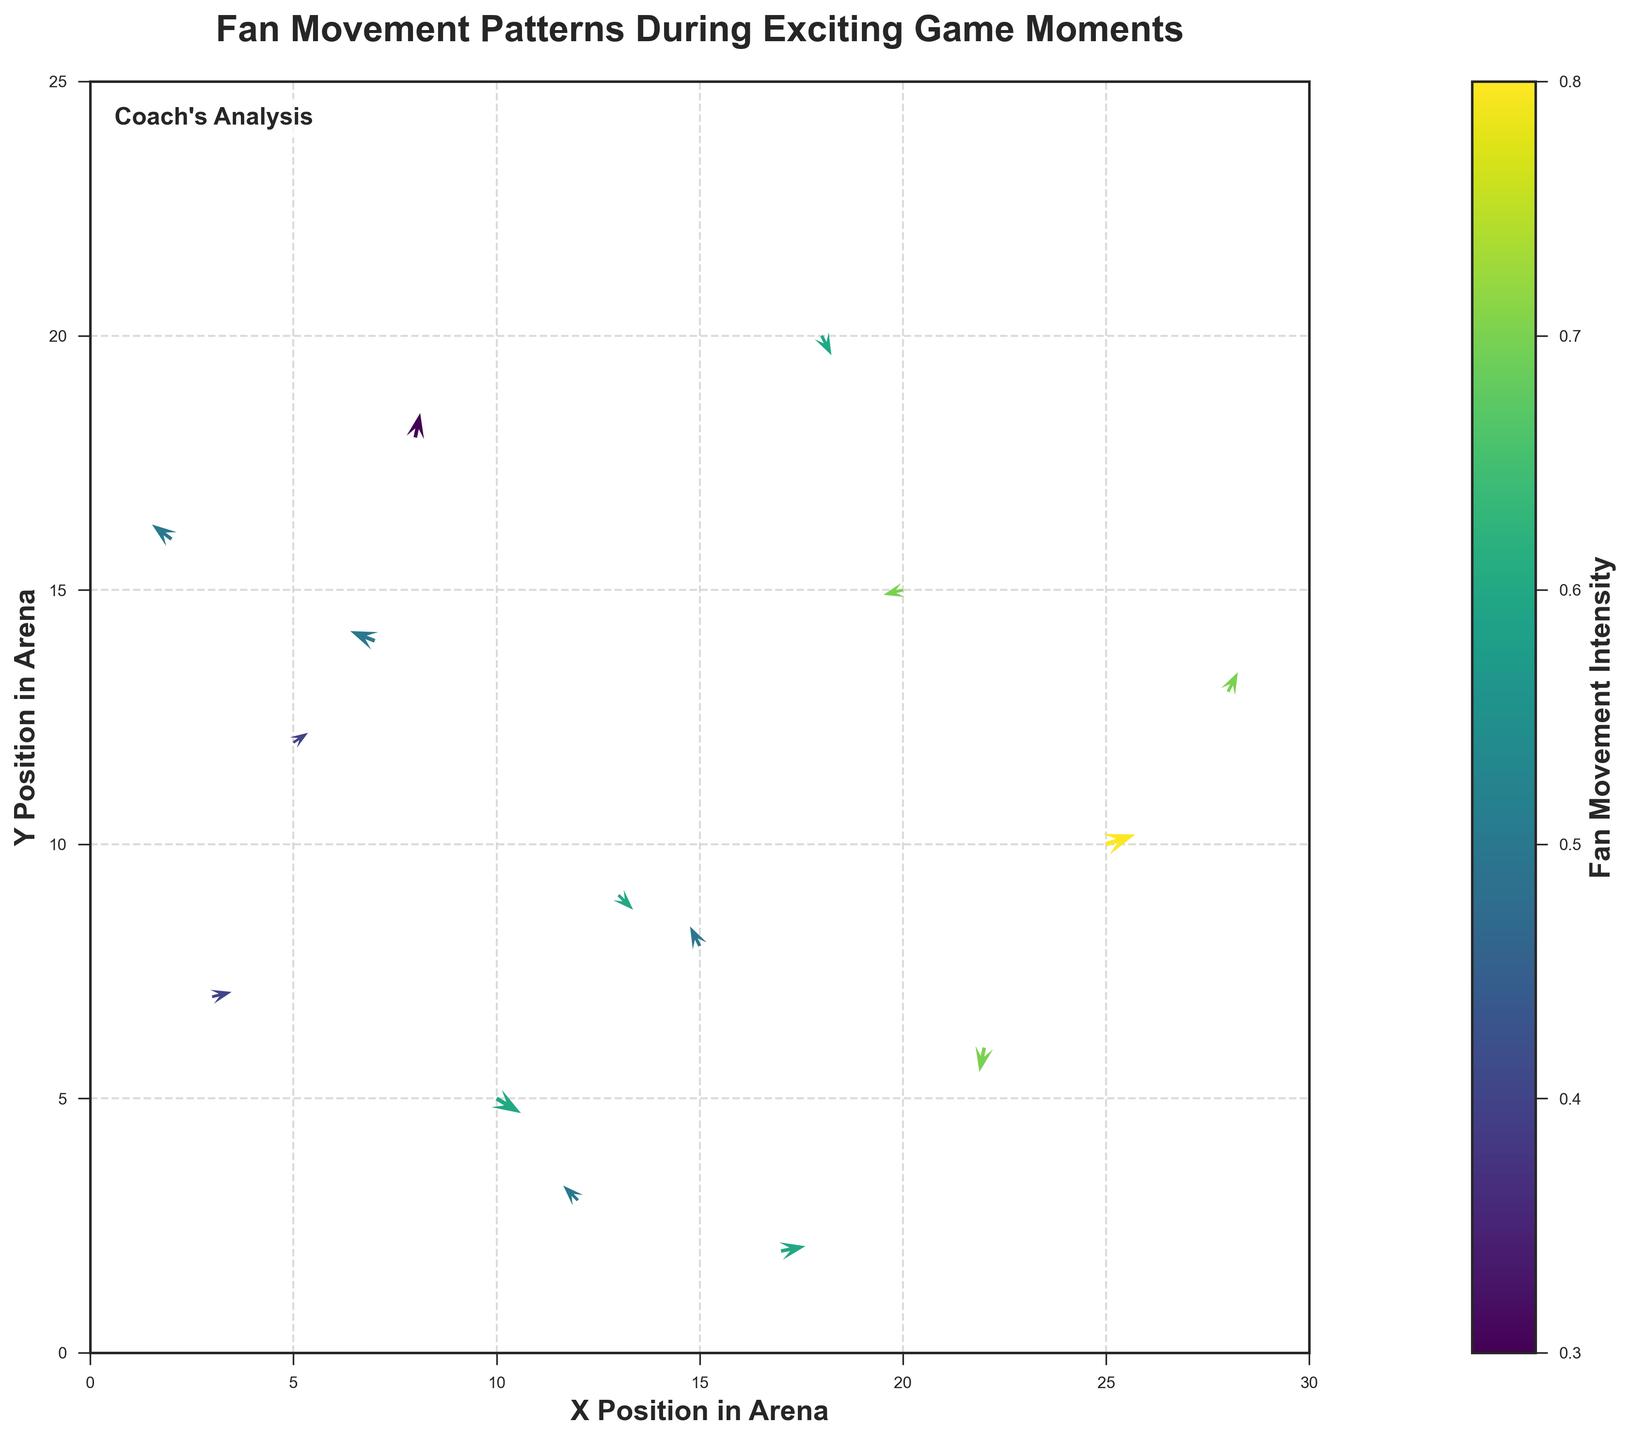What's the title of this figure? The title is written at the top of the chart and is typically a brief description of the data or visual. In this case, the title is "Fan Movement Patterns During Exciting Game Moments".
Answer: Fan Movement Patterns During Exciting Game Moments How is the color of each vector determined? The color of each vector is determined by the fan movement intensity, indicated by a color bar at the side of the plot. Darker colors represent higher intensity, and lighter colors represent lower intensity.
Answer: By fan movement intensity What are the labels for the x and y axes? The labels for the axes provide context about the data being represented. Here, the x-axis is labeled "X Position in Arena" and the y-axis is labeled "Y Position in Arena".
Answer: X Position in Arena and Y Position in Arena How many vectors are represented in the plot? The quiver plot shows fan movements at various points. Counting the number of starting points of the vectors (arrows), we find there are 15 vectors represented.
Answer: 15 Which vector has the highest movement intensity and what are its coordinates? To find the vector with the highest intensity, we can compare the color against the intensity color bar. The vector at coordinates (25, 10) has an intensity of 0.8, the highest value.
Answer: (25, 10) Which vector shows the largest movement in the positive x-direction? The vector pointing the farthest right horizontally indicates the largest positive x-movement. This is the vector at (25, 10) with components (0.6, 0.2).
Answer: (25, 10) Are there any vectors indicating zero movement? Vectors indicating zero movement would be difficult to see since they would be points without direction. In this plot, there are no vectors without direction, indicating all have some movement.
Answer: No Which position has the greatest intensity within the top half of the plot? The top half of the plot is the y-coordinate values above 12. The vector at (20, 15) within the top half has an intensity of 0.7, the highest in that region.
Answer: (20, 15) What direction is the vector at (7, 14) pointing? The direction of a vector is indicated by its u and v components. The vector at (7, 14) points in a direction of (-0.5, 0.2), which means it is moving left and slightly up.
Answer: Left and up Compare the movements between vectors at (10, 5) and (18, 20), which one shows a downward movement? The movement direction can be inferred from the v component. The vector at (10, 5) has components (0.5, -0.3) indicating a downward movement, while the vector at (18, 20) with components (0.2, -0.4) also shows a downward movement.
Answer: Both 